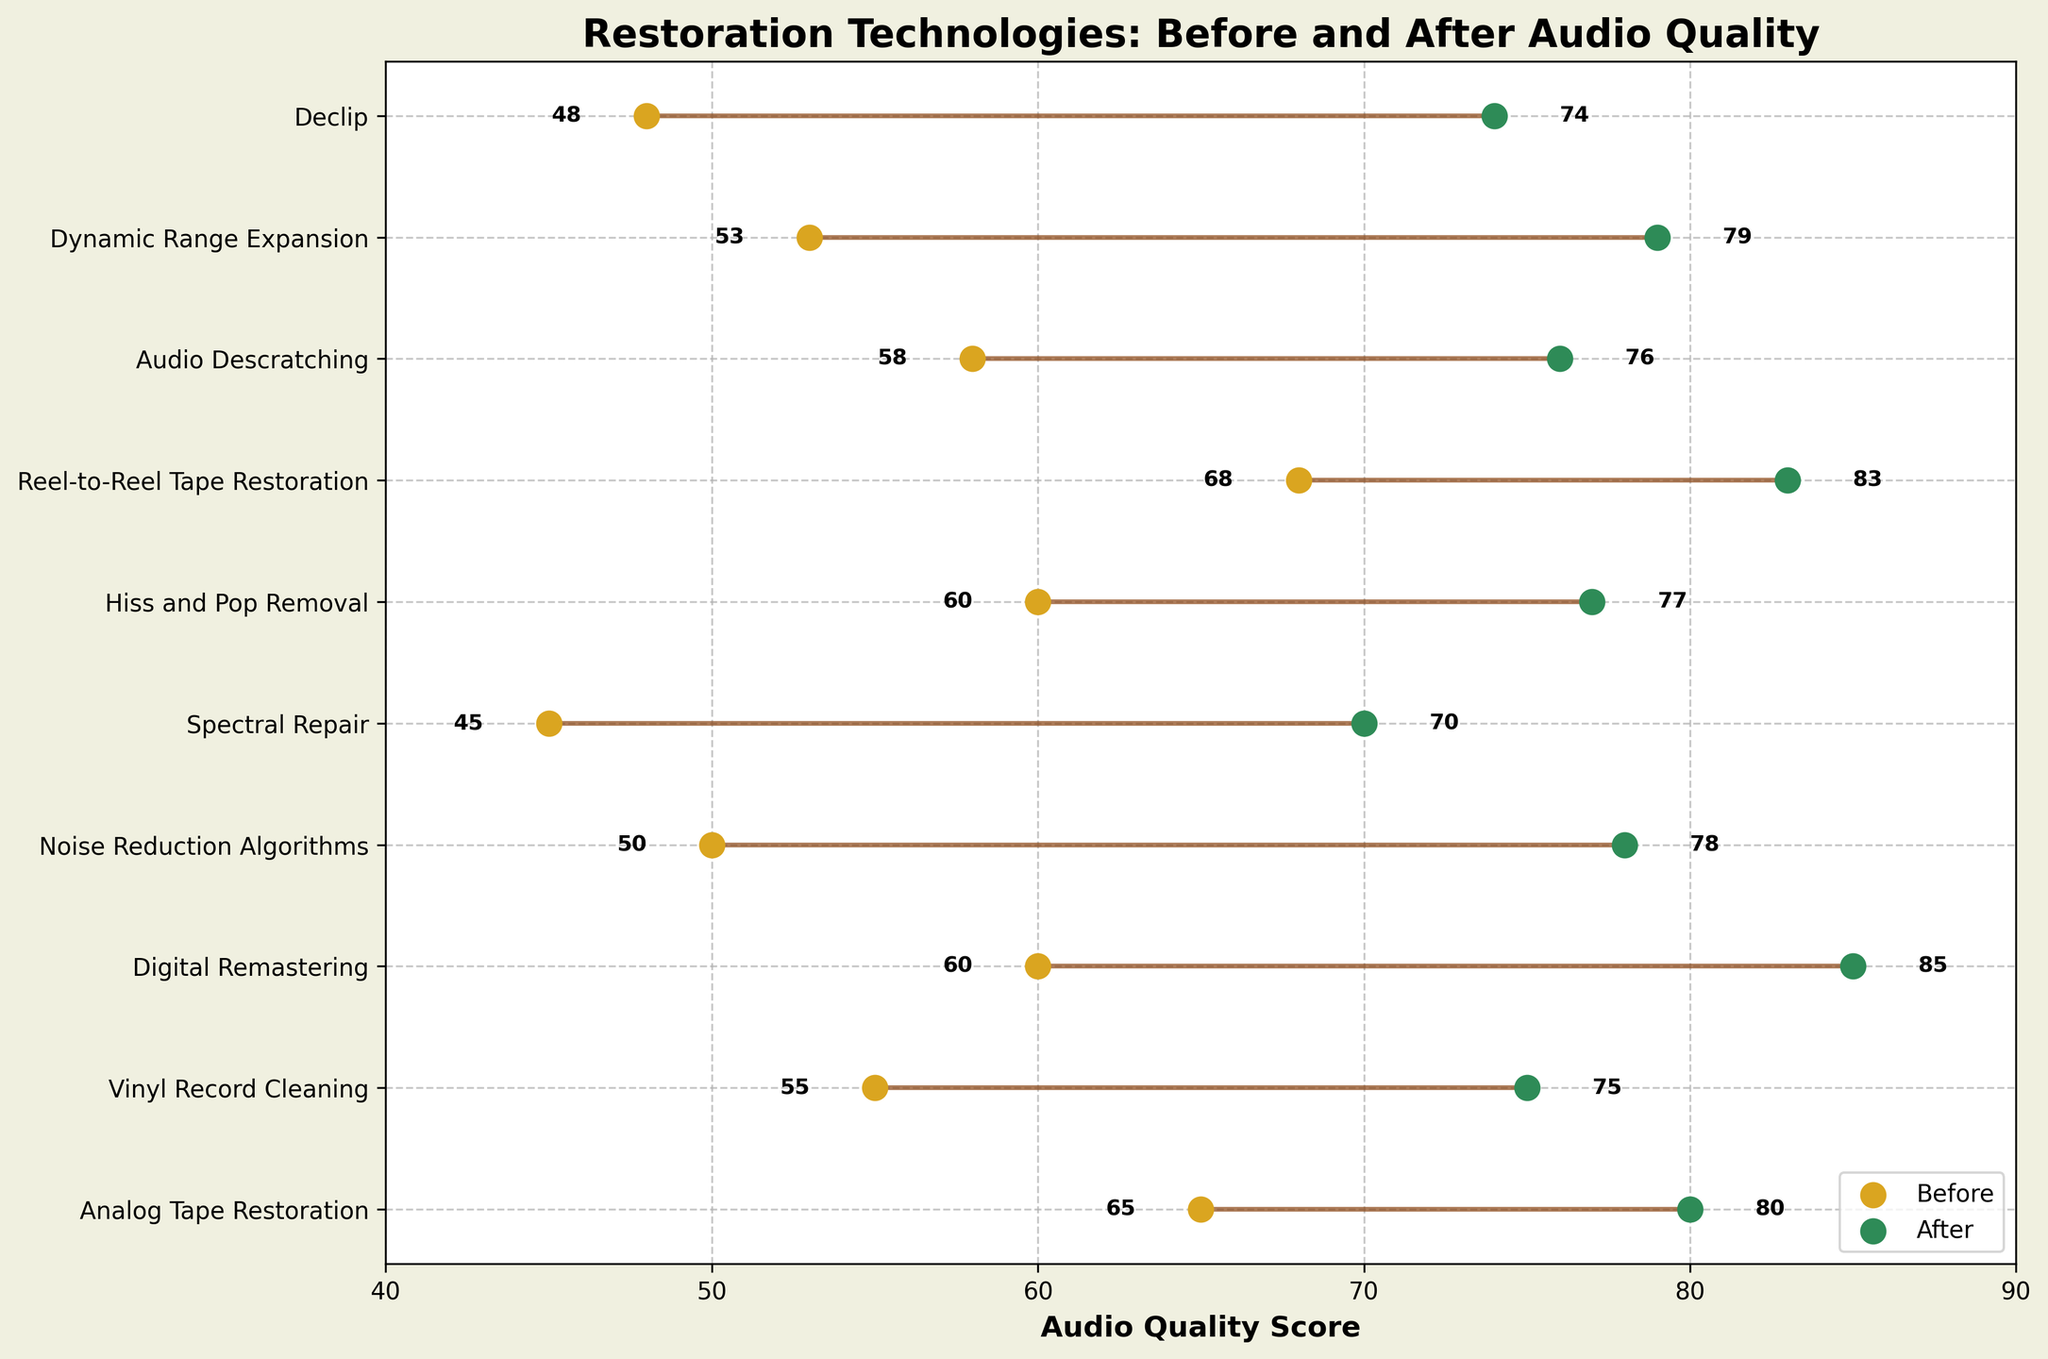What is the title of the figure? The title is typically located at the top of the figure. Reading the text there tells us the figure's title.
Answer: Restoration Technologies: Before and After Audio Quality How many restoration technologies are shown in the figure? Count the number of unique technologies listed on the y-axis.
Answer: 10 Which restoration technology shows the highest after audio quality score? Look at the 'After' points along the x-axis and identify the highest value point. The corresponding technology on the y-axis is the answer.
Answer: Digital Remastering What is the difference in audio quality before and after for Spectral Repair? Locate "Spectral Repair" on the y-axis and identify its 'Before' and 'After' points. Subtract the 'Before' value from the 'After' value.
Answer: 25 (70 - 45 = 25) How does Analog Tape Restoration compare to Reel-to-Reel Tape Restoration in terms of improvement in audio quality? Calculate the difference between 'Before' and 'After' for both technologies, then compare the two differences to see which is greater.
Answer: Analog Tape Restoration: 15 (80 - 65); Reel-to-Reel Tape Restoration: 15 (83 - 68); they are the same What is the average before audio quality score of all technologies? Sum all the 'Before' scores and divide by the number of technologies.
Answer: (65 + 55 + 60 + 50 + 45 + 60 + 68 + 58 + 53 + 48) / 10 = 56.2 What is the median after audio quality score across all technologies? Line up all 'After' scores in ascending order, and identify the middle value (or the average of the two middle values if even number of data points).
Answer: 77.5 Which two technologies show the greatest improvement in audio quality? Calculate the difference between 'Before' and 'After' scores for all technologies. Identify the two with the highest differences.
Answer: Digital Remastering (25), Noise Reduction Algorithms (28) Is there a technology that has the same score for before and after audio quality? Review all scores to see if any technology has identical 'Before' and 'After' values.
Answer: No What is the range of after audio quality scores? Find the minimum and maximum 'After' scores, then subtract the minimum from the maximum.
Answer: 40 (85 - 45) 